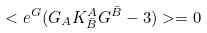<formula> <loc_0><loc_0><loc_500><loc_500>< e ^ { G } ( G _ { A } K ^ { A } _ { \bar { B } } G ^ { \bar { B } } - 3 ) > = 0</formula> 